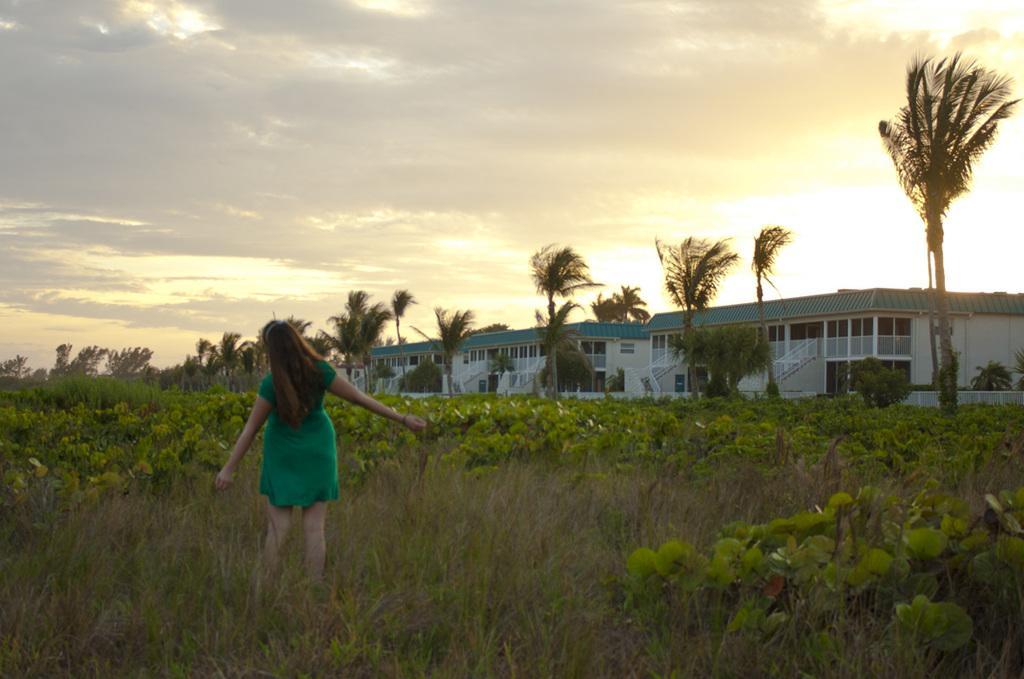Could you give a brief overview of what you see in this image? In this image I can see a person standing wearing green color dress. Background I can see trees in green color, buildings in white and green color and sky in white and gray color. 